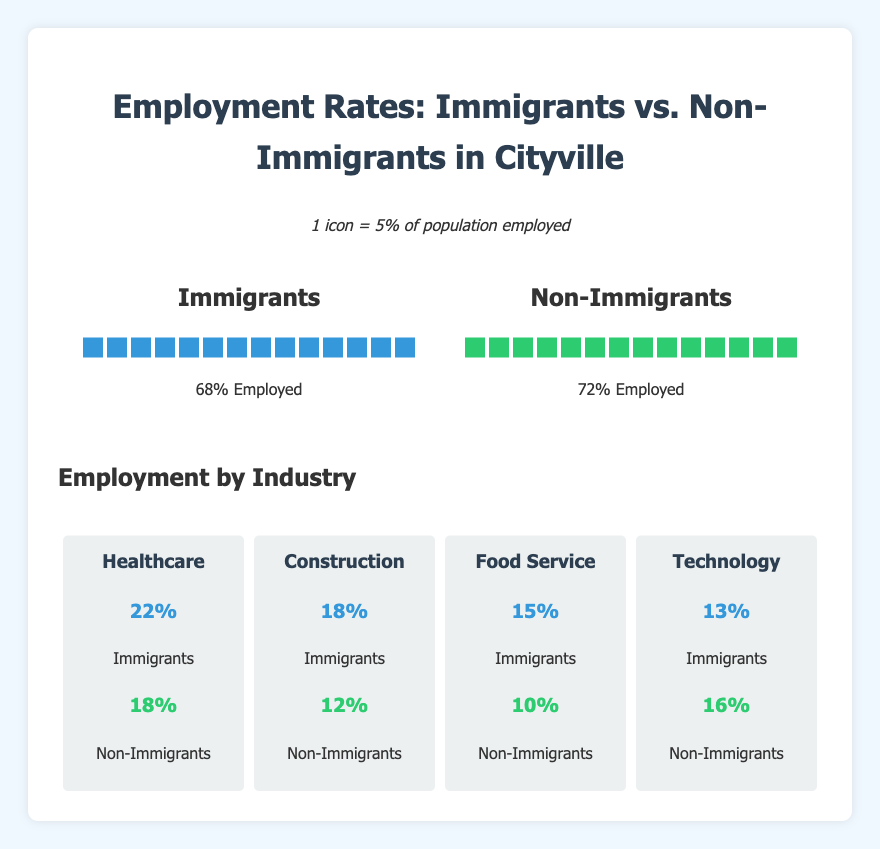What is the employment rate for immigrants in Cityville? The employment rate is visualized by counting the icons in the "Immigrants" section. Each icon represents 5%, and there are 14 icons. Therefore, the employment rate is 14 icons * 5% per icon.
Answer: 68% What industry has the highest percentage of non-immigrant employees? Look at the "Employment by Industry" section. The industry with the highest non-immigrant percentage is indicated by the largest percentage value in the non-immigrant category.
Answer: Technology How much higher is the employment rate for non-immigrants compared to immigrants? The employment rate for non-immigrants is 72% and for immigrants is 68%. The difference is 72% - 68%.
Answer: 4% Which industry has the largest difference in employment between immigrants and non-immigrants? Compare the immigrant and non-immigrant percentages for each industry and find the industry with the largest absolute difference between the two percentages.
Answer: Healthcare How many icons represent the non-immigrant employment rate? Count the icons in the "Non-Immigrants" section. Each icon represents 5%, and there are 14 icons. Therefore, the number of icons is 14.
Answer: 14 What are the two industries where immigrants have a higher employment percentage than non-immigrants, and what are their percentages? Compare the immigrant and non-immigrant employment percentages for each industry. The industries with higher immigrant percentages are Healthcare and Construction.
Answer: Healthcare: 22% and Construction: 18% Which industry shows a higher percentage of immigrant employment compared to non-immigrant employment by exactly 5%? Look through each industry and find the one where the immigrant percentage is exactly 5% higher than the non-immigrant percentage.
Answer: Food Service What percentage of immigrants work in the Technology industry? Refer to the "Employment by Industry" section and check the immigrant percentage for the Technology industry.
Answer: 13% Which employment rate is displayed with fewer icons on the isotype chart? Compare the number of icons in the "Immigrants" and "Non-Immigrants" sections. The "Immigrants" section has fewer icons.
Answer: Immigrants By how many percentage points is the non-immigrant employment rate in Technology higher than the immigrant employment rate in the same industry? The non-immigrant employment rate in Technology is 16%, and the immigrant rate is 13%. The difference is 16% - 13%.
Answer: 3% 